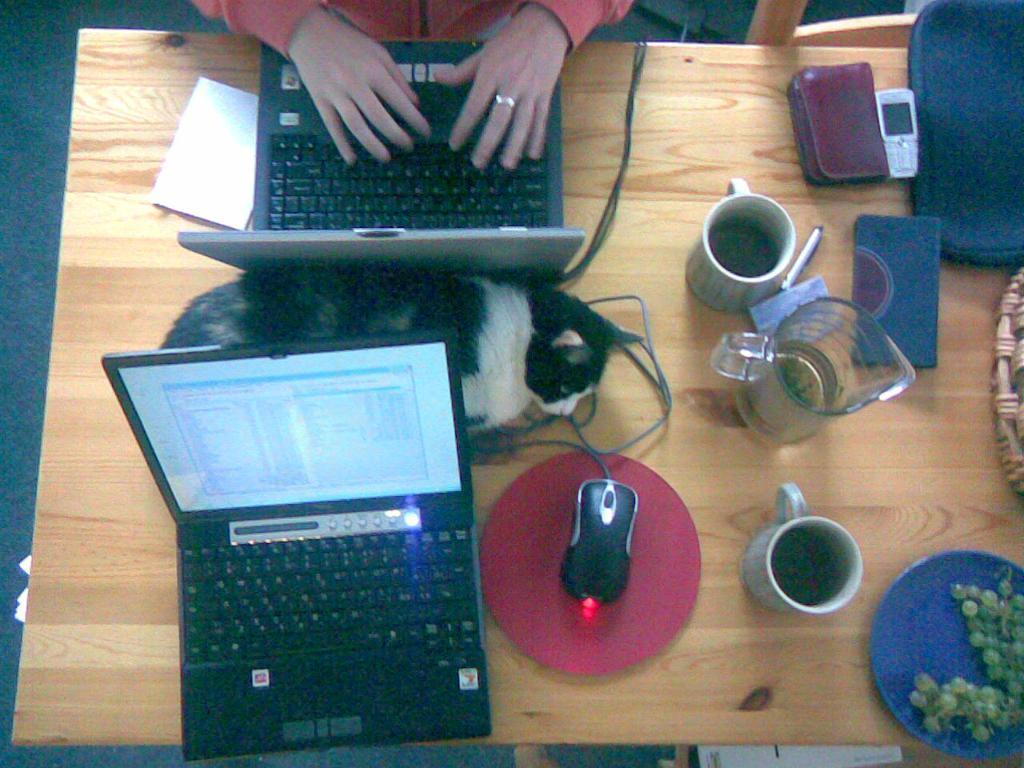Describe this image in one or two sentences. In this image we can see a cat is sleeping in between two laptops,. There are mouse, cups, jar, mobile phones, plates and fruits on the table. 